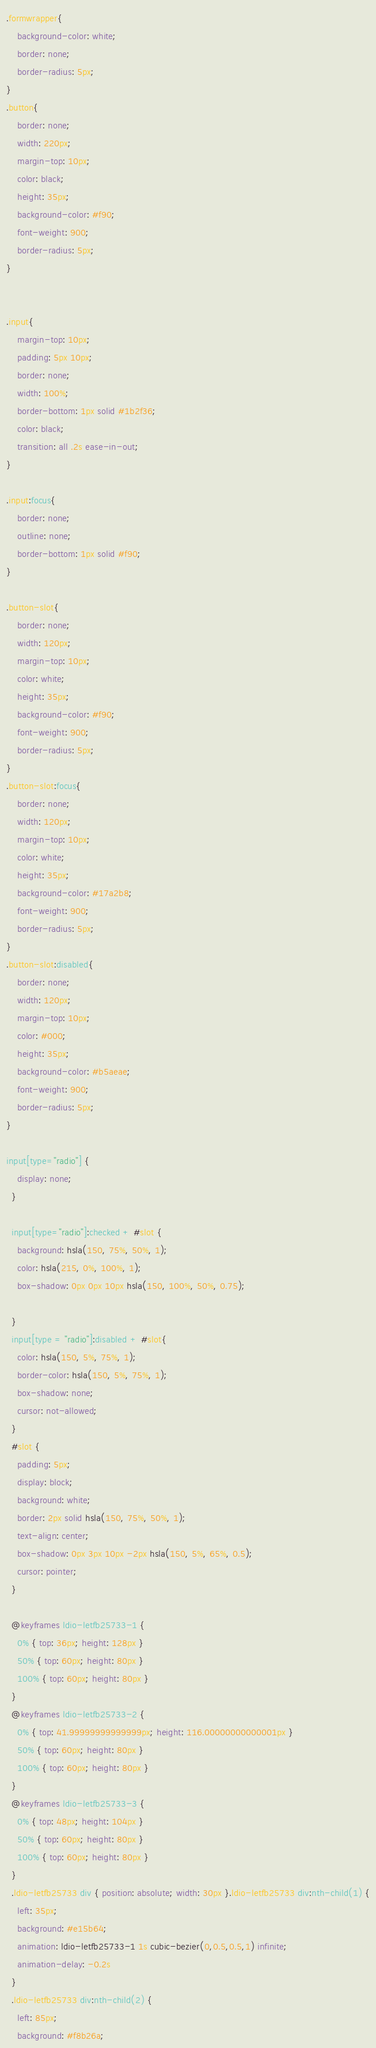<code> <loc_0><loc_0><loc_500><loc_500><_CSS_>.formwrapper{
    background-color: white;
    border: none;
    border-radius: 5px;
}
.button{
    border: none;
    width: 220px;
    margin-top: 10px;
    color: black;
    height: 35px;
    background-color: #f90;
    font-weight: 900;
    border-radius: 5px;
}


.input{
    margin-top: 10px;
    padding: 5px 10px;
    border: none;
    width: 100%;
    border-bottom: 1px solid #1b2f36;
    color: black;
    transition: all .2s ease-in-out;
}

.input:focus{
    border: none;
    outline: none;
    border-bottom: 1px solid #f90;   
}

.button-slot{
    border: none;
    width: 120px;
    margin-top: 10px;
    color: white;
    height: 35px;
    background-color: #f90;
    font-weight: 900;
    border-radius: 5px;
}
.button-slot:focus{
    border: none;
    width: 120px;
    margin-top: 10px;
    color: white;
    height: 35px;
    background-color: #17a2b8;
    font-weight: 900;
    border-radius: 5px;
}
.button-slot:disabled{
    border: none;
    width: 120px;
    margin-top: 10px;
    color: #000;
    height: 35px;
    background-color: #b5aeae;
    font-weight: 900;
    border-radius: 5px;
}

input[type="radio"] {
    display: none;
  }

  input[type="radio"]:checked + #slot {
    background: hsla(150, 75%, 50%, 1);
    color: hsla(215, 0%, 100%, 1);
    box-shadow: 0px 0px 10px hsla(150, 100%, 50%, 0.75);

  }
  input[type = "radio"]:disabled + #slot{
    color: hsla(150, 5%, 75%, 1);
    border-color: hsla(150, 5%, 75%, 1);
    box-shadow: none;
    cursor: not-allowed;
  }
  #slot {
    padding: 5px;
    display: block;
    background: white;
    border: 2px solid hsla(150, 75%, 50%, 1);
    text-align: center;
    box-shadow: 0px 3px 10px -2px hsla(150, 5%, 65%, 0.5);
    cursor: pointer;
  }     
 
  @keyframes ldio-letfb25733-1 {
    0% { top: 36px; height: 128px }
    50% { top: 60px; height: 80px }
    100% { top: 60px; height: 80px }
  }
  @keyframes ldio-letfb25733-2 {
    0% { top: 41.99999999999999px; height: 116.00000000000001px }
    50% { top: 60px; height: 80px }
    100% { top: 60px; height: 80px }
  }
  @keyframes ldio-letfb25733-3 {
    0% { top: 48px; height: 104px }
    50% { top: 60px; height: 80px }
    100% { top: 60px; height: 80px }
  }
  .ldio-letfb25733 div { position: absolute; width: 30px }.ldio-letfb25733 div:nth-child(1) {
    left: 35px;
    background: #e15b64;
    animation: ldio-letfb25733-1 1s cubic-bezier(0,0.5,0.5,1) infinite;
    animation-delay: -0.2s
  }
  .ldio-letfb25733 div:nth-child(2) {
    left: 85px;
    background: #f8b26a;</code> 